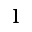<formula> <loc_0><loc_0><loc_500><loc_500>1</formula> 